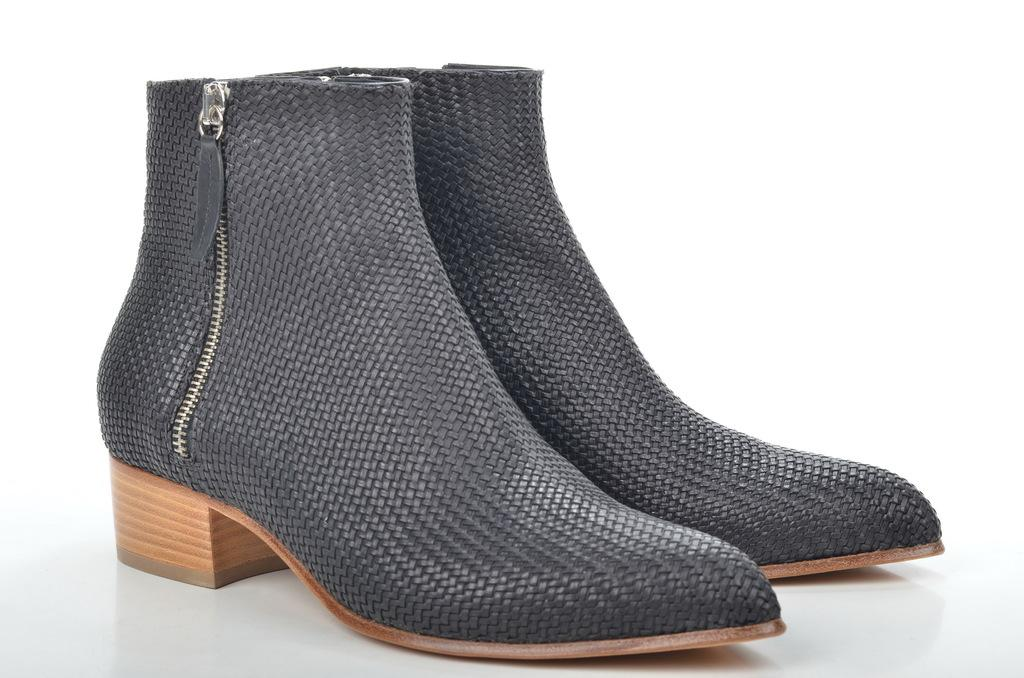What type of footwear is present in the image? There are boots in the image. What is the color of the surface on which the boots are placed? The boots are on a white surface. What is the predominant color of the image? The remaining portion of the image is in white color. Can you tell me how many goats are visible in the image? There are no goats present in the image; it only features boots on a white surface. What type of chicken is sitting on the boots in the image? There is no chicken present in the image; it only features boots on a white surface. 